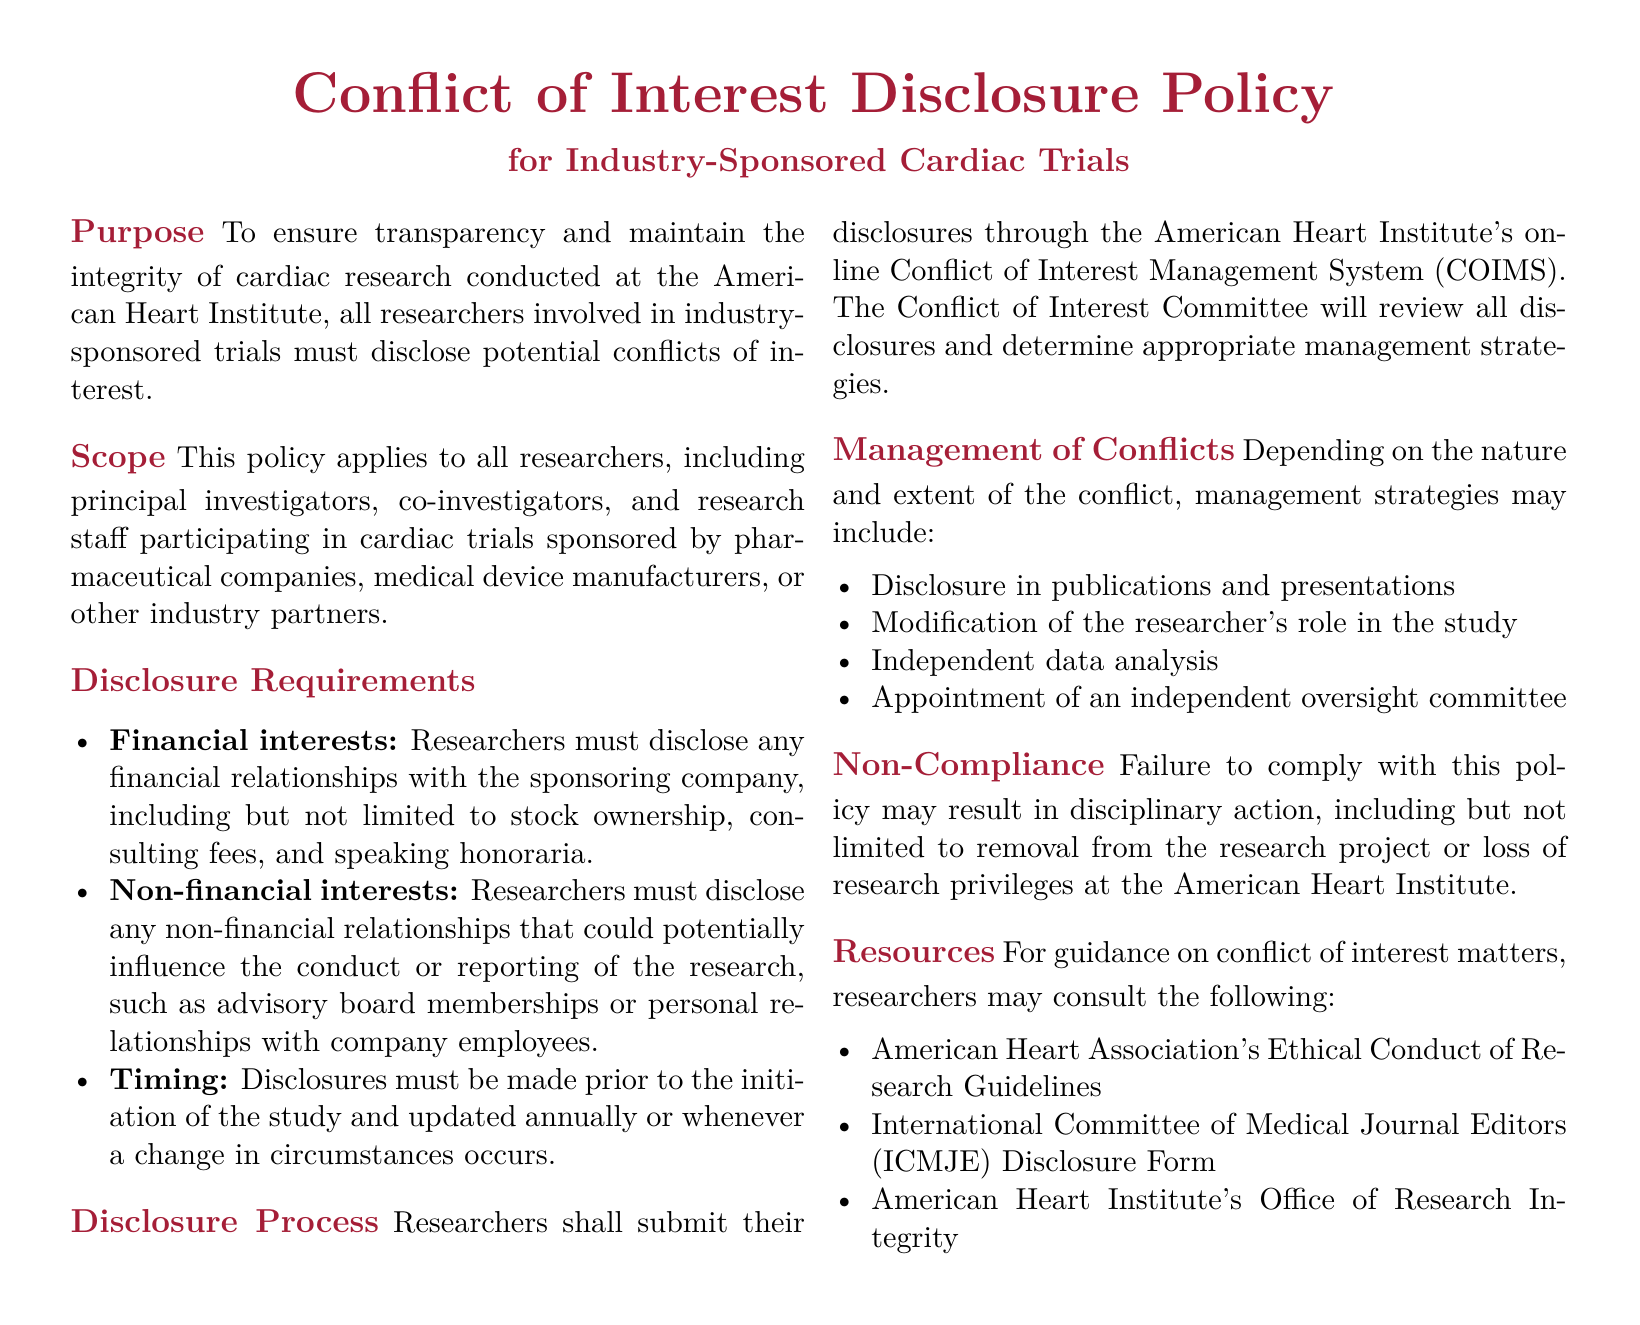What is the purpose of the policy? The purpose is to ensure transparency and maintain the integrity of cardiac research conducted at the American Heart Institute.
Answer: To ensure transparency and maintain the integrity of cardiac research Who must disclose potential conflicts of interest? The policy applies to all researchers involved in industry-sponsored trials, like principal investigators and research staff.
Answer: All researchers What types of financial interests must be disclosed? Researchers must disclose any financial relationships with the sponsoring company, including stock ownership and consulting fees.
Answer: Stock ownership, consulting fees When must disclosures be made? Disclosures must be made prior to the initiation of the study and updated annually or with changes.
Answer: Prior to the initiation of the study What committee reviews the disclosures? The Conflict of Interest Committee reviews all disclosures made by researchers.
Answer: Conflict of Interest Committee What could be a management strategy for conflicts? Management strategies may include disclosure in publications and presentations.
Answer: Disclosure in publications and presentations What can result from non-compliance with the policy? Failure to comply may result in disciplinary action, including removal from the research project.
Answer: Removal from the research project Which guidelines can researchers consult for guidance? Researchers may consult the American Heart Association's Ethical Conduct of Research Guidelines.
Answer: American Heart Association's Ethical Conduct of Research Guidelines What is the document type? The document type is a policy document related to conflict of interest disclosures for researchers.
Answer: Policy document 